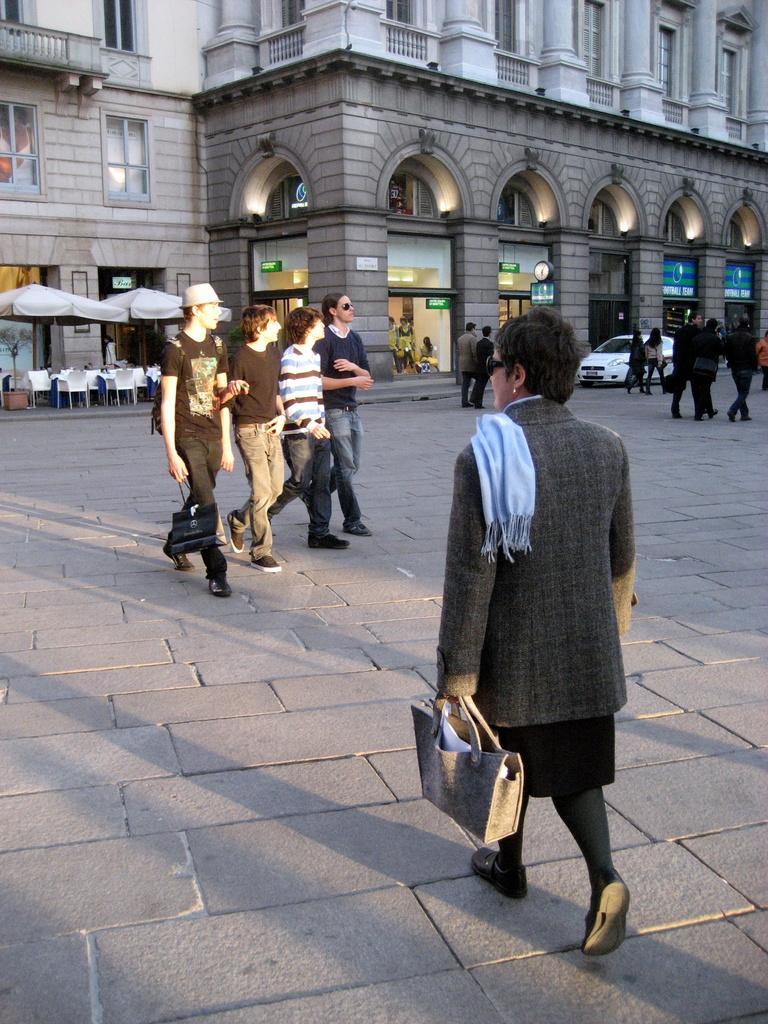Please provide a concise description of this image. Here we can see a group of people walking on the road and in front of them there is a building present and at the right side we can see a car and at the left side we can see umbrellas with chairs and tables below it 